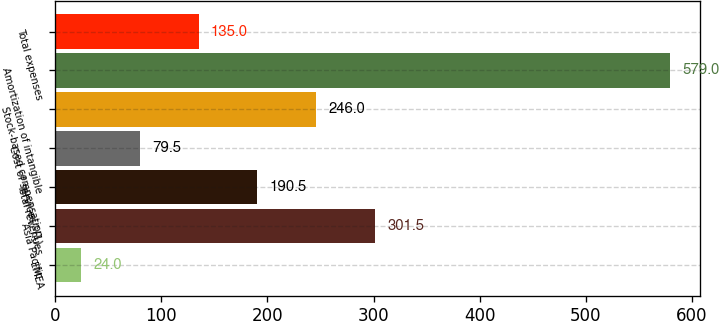Convert chart to OTSL. <chart><loc_0><loc_0><loc_500><loc_500><bar_chart><fcel>EMEA<fcel>Asia Pacific<fcel>Total revenues<fcel>Cost of services^(1)<fcel>Stock-based compensation<fcel>Amortization of intangible<fcel>Total expenses<nl><fcel>24<fcel>301.5<fcel>190.5<fcel>79.5<fcel>246<fcel>579<fcel>135<nl></chart> 